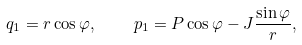Convert formula to latex. <formula><loc_0><loc_0><loc_500><loc_500>q _ { 1 } = r \cos \varphi , \quad p _ { 1 } = P \cos \varphi - J \frac { \sin \varphi } { r } ,</formula> 